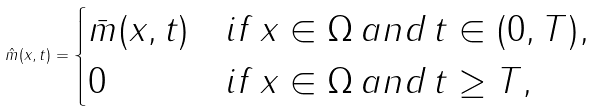Convert formula to latex. <formula><loc_0><loc_0><loc_500><loc_500>\hat { m } ( x , t ) = \begin{cases} \bar { m } ( x , t ) & i f \, x \in \Omega \, a n d \, t \in ( 0 , T ) , \\ 0 & i f \, x \in \Omega \, a n d \, t \geq T , \end{cases}</formula> 